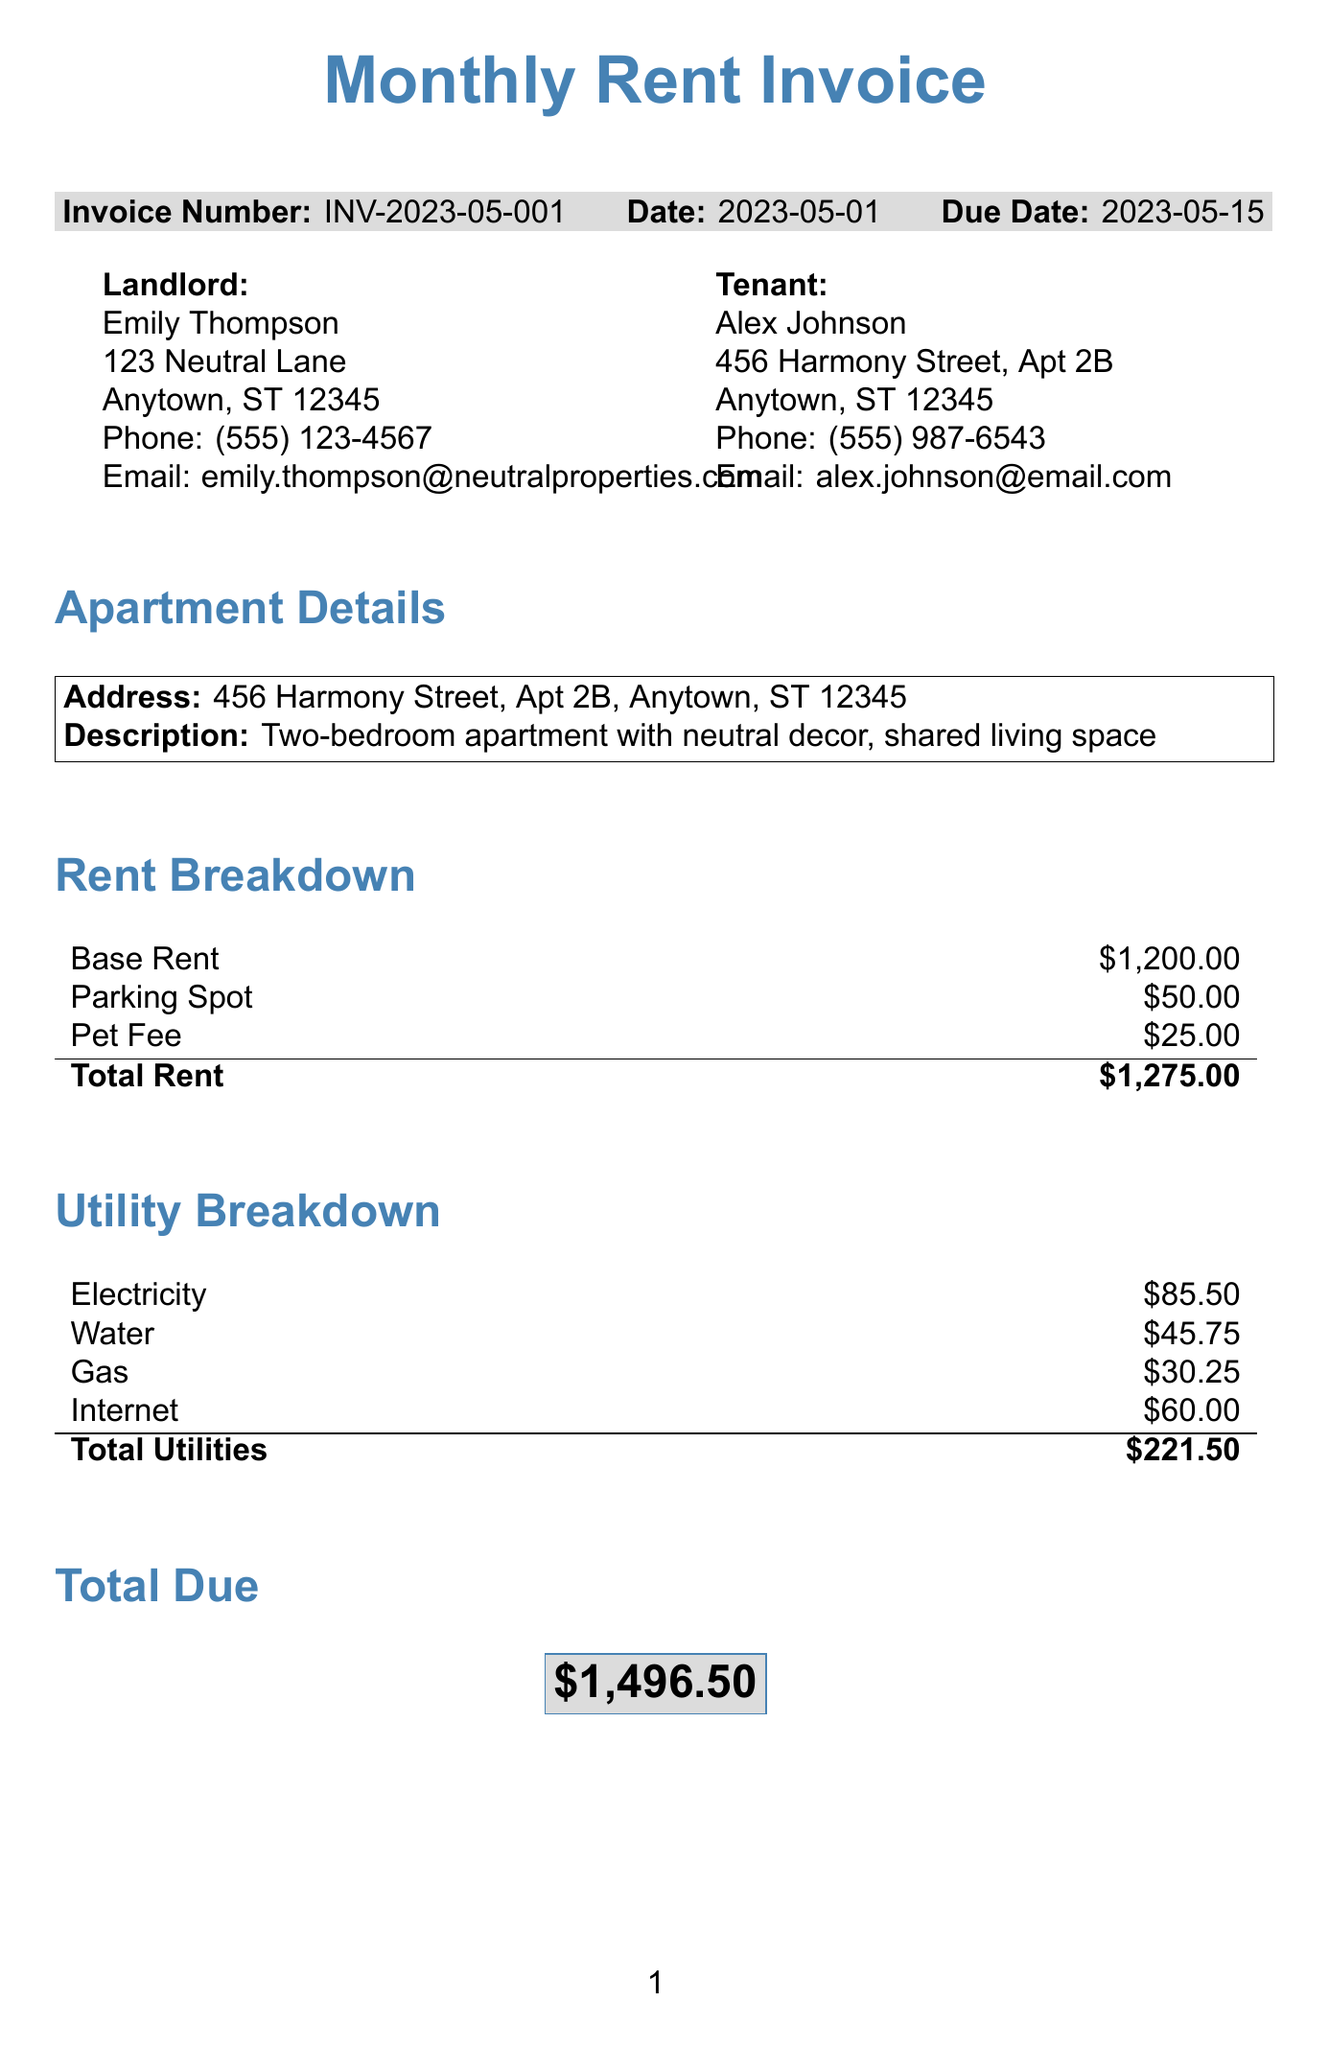What is the invoice number? The invoice number is a unique identifier for the invoice, which is listed in the document as INV-2023-05-001.
Answer: INV-2023-05-001 What is the total due amount? The total due amount is the sum of total rent and total utilities, which is stated in the document as $1,496.50.
Answer: $1,496.50 Who is the landlord? The landlord's name is provided in the document as Emily Thompson.
Answer: Emily Thompson What is the base rent amount? The base rent is specified in the rent breakdown section of the document as $1,200.00.
Answer: $1,200.00 How much is the pet fee? The pet fee amount is given in the rent breakdown, which states it is $25.00.
Answer: $25.00 What utilities are included in the utility breakdown? The document lists electricity, water, gas, and internet as the included utilities in the breakdown.
Answer: Electricity, water, gas, internet Which payment method requires a payable name? The payment method that requires a name to be made payable is the check option.
Answer: Check When is the payment due date? The due date for payment is stated in the document as 2023-05-15.
Answer: 2023-05-15 What is the description of the apartment? The apartment description is provided in the document as a two-bedroom apartment with neutral decor, shared living space.
Answer: Two-bedroom apartment with neutral decor, shared living space What should you do for maintenance requests? The document advises using the neutral-toned request form located in the common area for maintenance requests.
Answer: Use the neutral-toned request form in the common area 